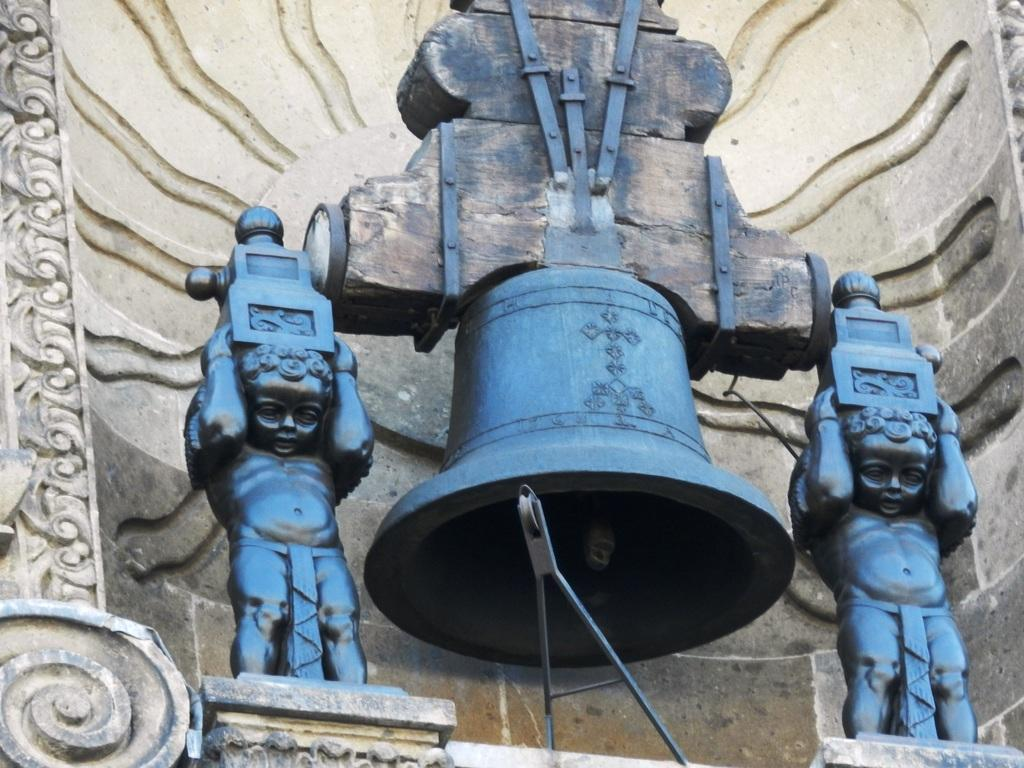What is the main object in the center of the image? There is a bell in the center of the image. Are there any people or figures in the image? Yes, there are two depictions of a boy in the image. What can be seen in the background of the image? There is a wall in the background of the image. What type of animal is hiding under the bell in the image? There is no animal present in the image, and the bell is not covering anything. 